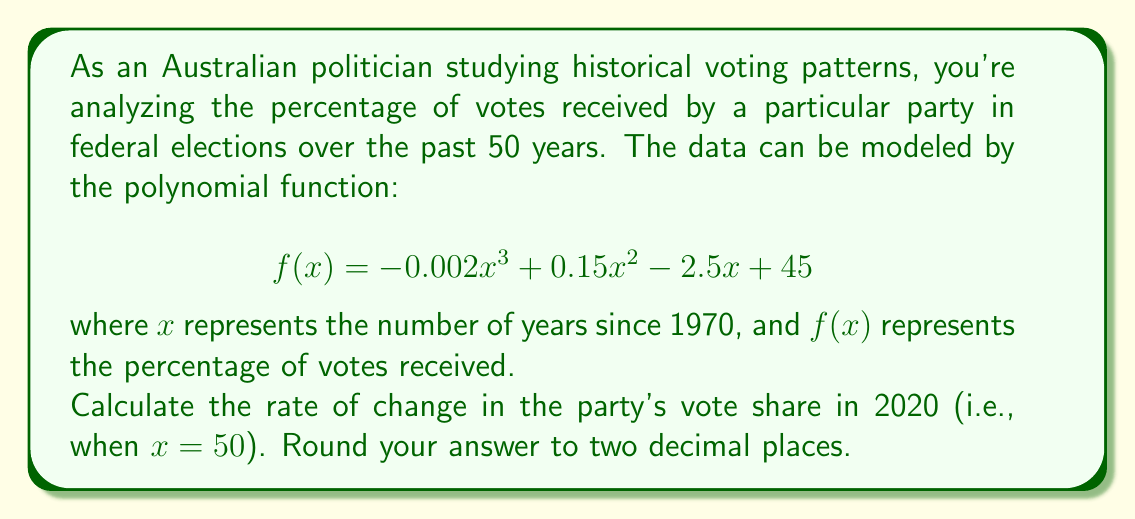Could you help me with this problem? To find the rate of change in the party's vote share in 2020, we need to calculate the derivative of the given function $f(x)$ and evaluate it at $x = 50$. 

1) First, let's find the derivative of $f(x)$:

   $f(x) = -0.002x^3 + 0.15x^2 - 2.5x + 45$
   
   $f'(x) = -0.006x^2 + 0.3x - 2.5$

2) Now, we need to evaluate $f'(50)$:

   $f'(50) = -0.006(50)^2 + 0.3(50) - 2.5$
   
   $= -0.006(2500) + 15 - 2.5$
   
   $= -15 + 15 - 2.5$
   
   $= -2.5$

3) The rate of change is negative, indicating a decreasing trend in the party's vote share.

4) Rounding to two decimal places:

   $-2.5$ rounded to two decimal places is $-2.50$

Therefore, in 2020, the rate of change in the party's vote share was -2.50 percentage points per year.
Answer: $-2.50$ percentage points per year 